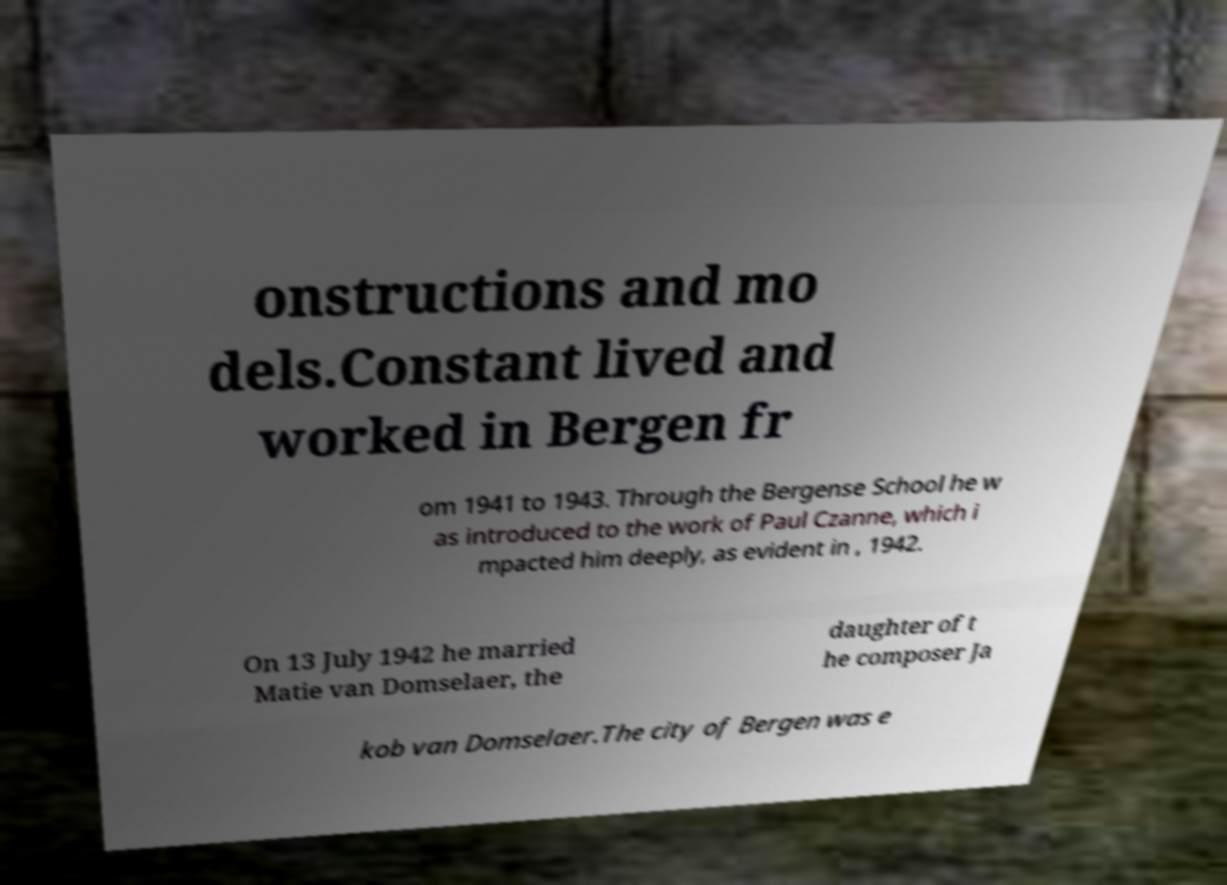What messages or text are displayed in this image? I need them in a readable, typed format. onstructions and mo dels.Constant lived and worked in Bergen fr om 1941 to 1943. Through the Bergense School he w as introduced to the work of Paul Czanne, which i mpacted him deeply, as evident in , 1942. On 13 July 1942 he married Matie van Domselaer, the daughter of t he composer Ja kob van Domselaer.The city of Bergen was e 